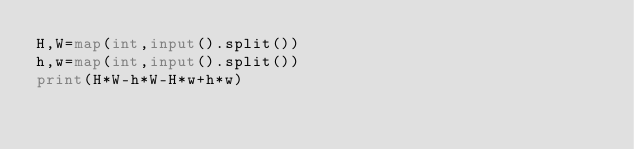Convert code to text. <code><loc_0><loc_0><loc_500><loc_500><_Python_>H,W=map(int,input().split())
h,w=map(int,input().split())
print(H*W-h*W-H*w+h*w)</code> 